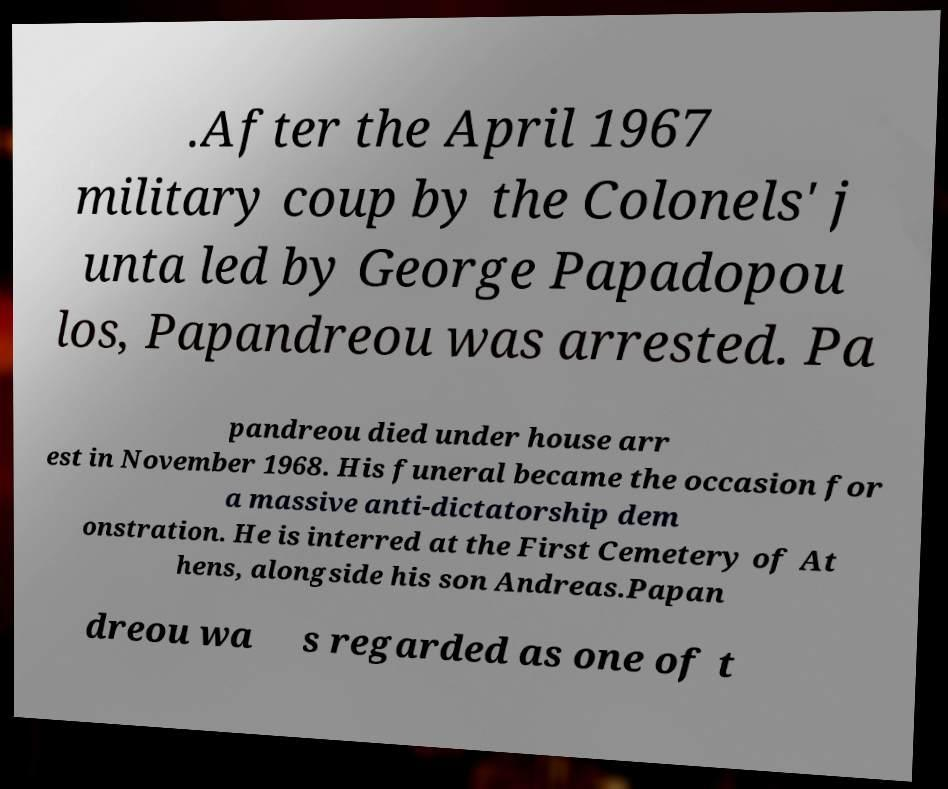Please read and relay the text visible in this image. What does it say? .After the April 1967 military coup by the Colonels' j unta led by George Papadopou los, Papandreou was arrested. Pa pandreou died under house arr est in November 1968. His funeral became the occasion for a massive anti-dictatorship dem onstration. He is interred at the First Cemetery of At hens, alongside his son Andreas.Papan dreou wa s regarded as one of t 